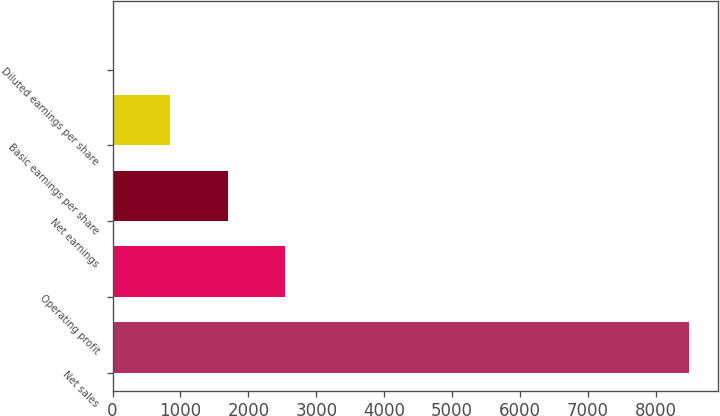Convert chart. <chart><loc_0><loc_0><loc_500><loc_500><bar_chart><fcel>Net sales<fcel>Operating profit<fcel>Net earnings<fcel>Basic earnings per share<fcel>Diluted earnings per share<nl><fcel>8488<fcel>2546.99<fcel>1698.27<fcel>849.55<fcel>0.83<nl></chart> 